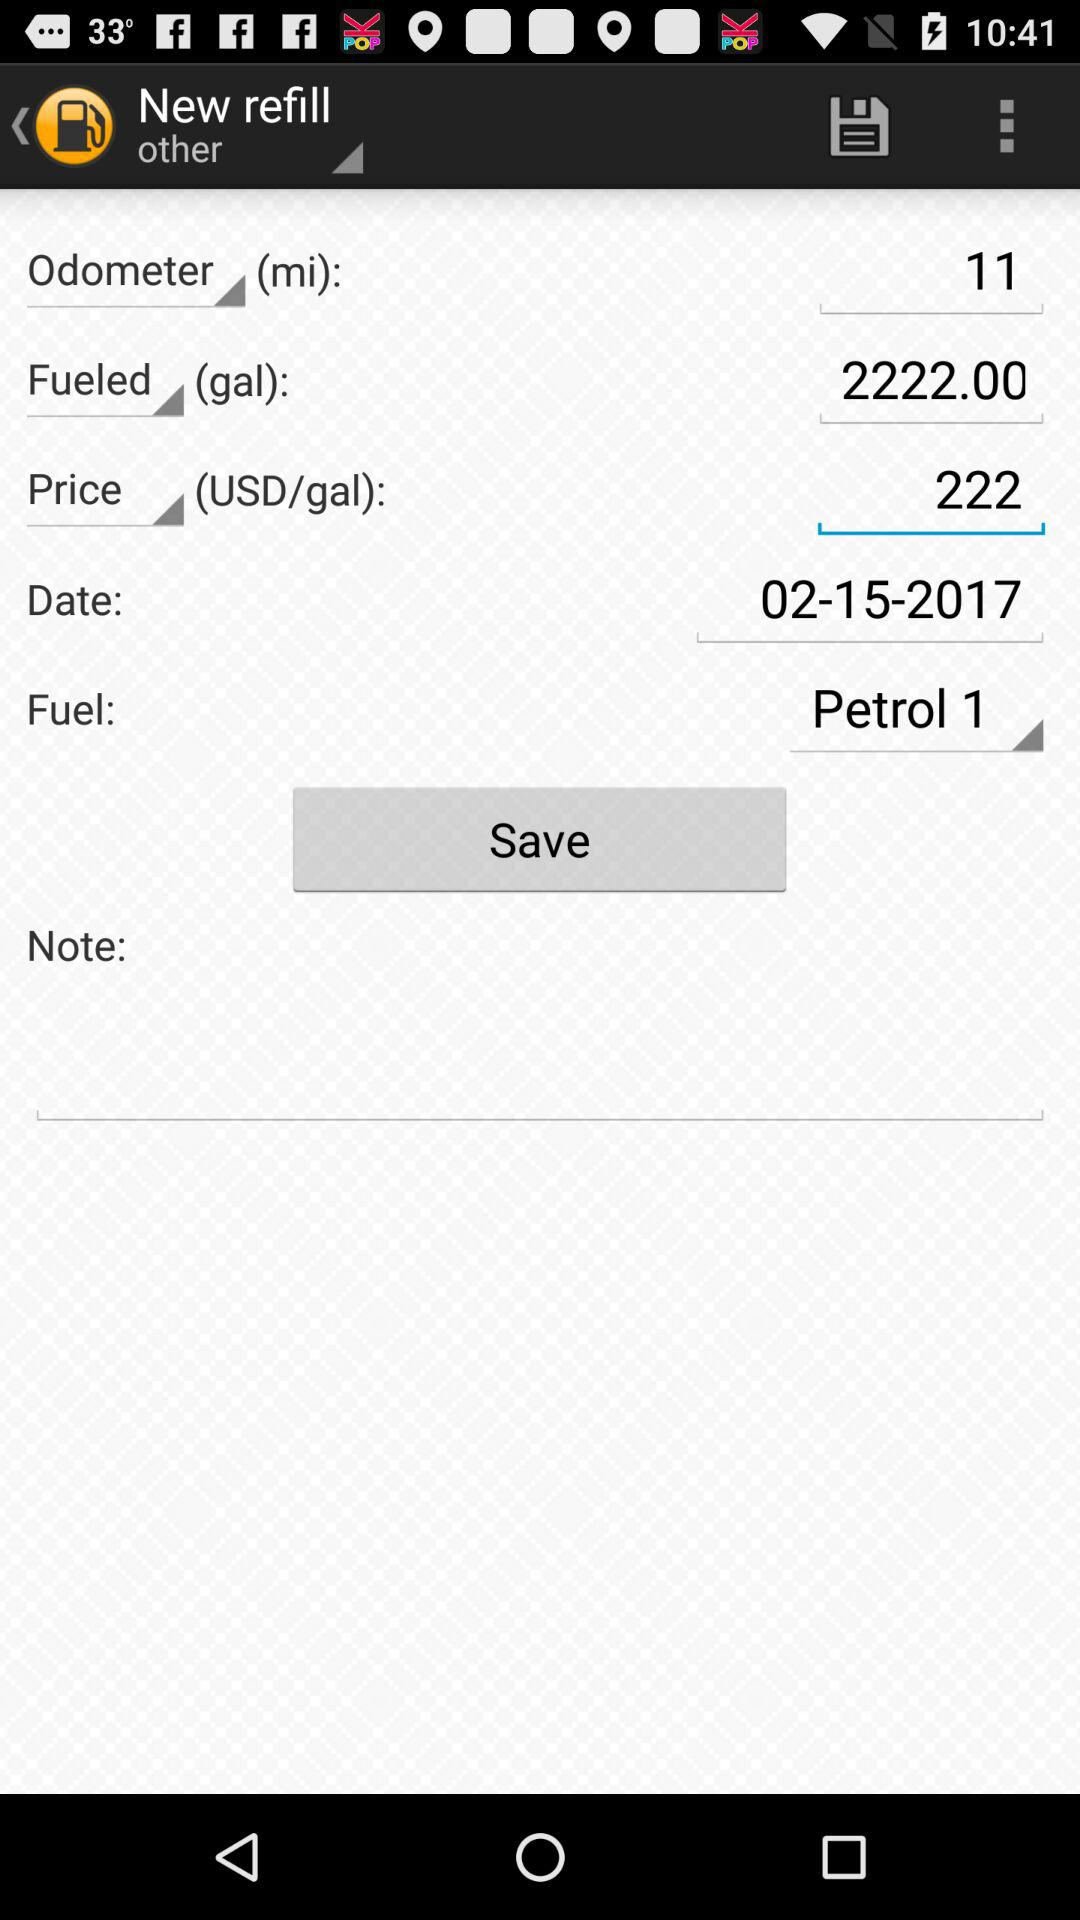What is the odometer reading? The odometer reading is 11 miles. 